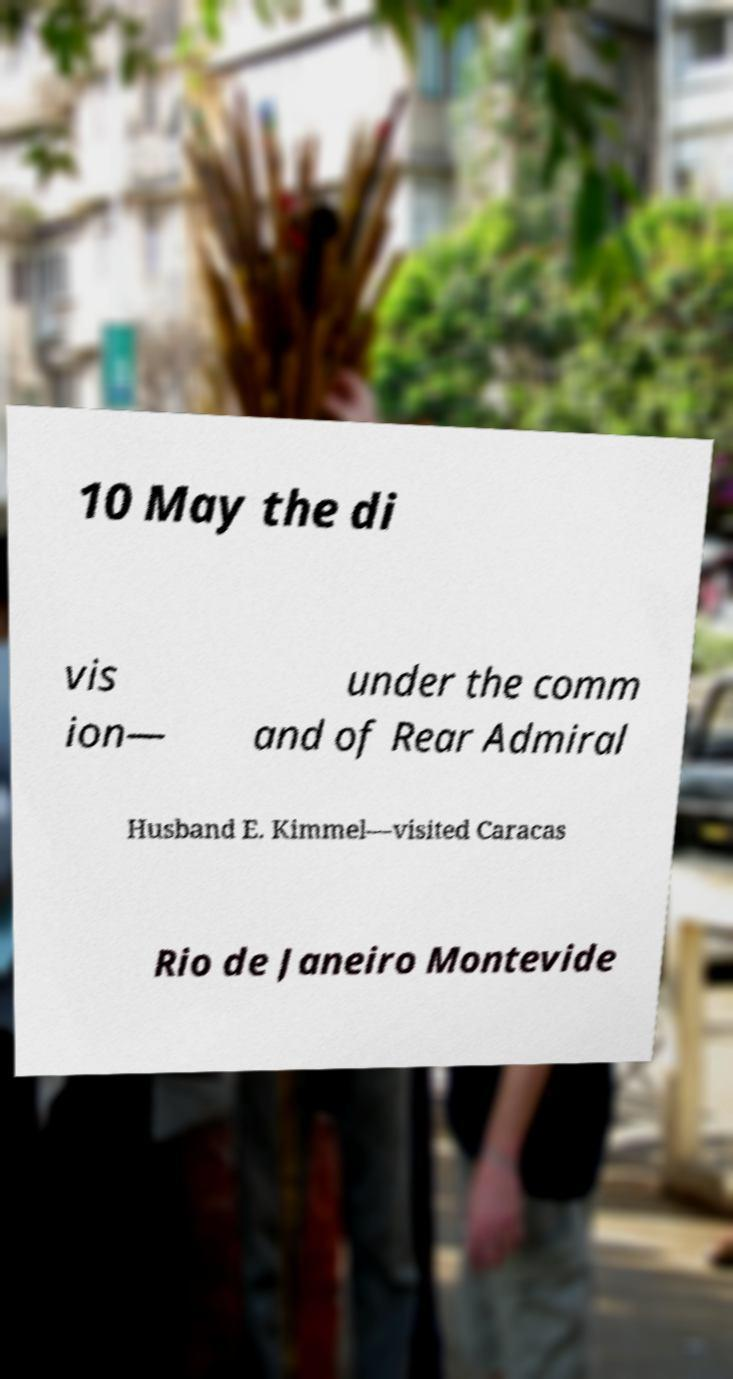Please identify and transcribe the text found in this image. 10 May the di vis ion— under the comm and of Rear Admiral Husband E. Kimmel—visited Caracas Rio de Janeiro Montevide 